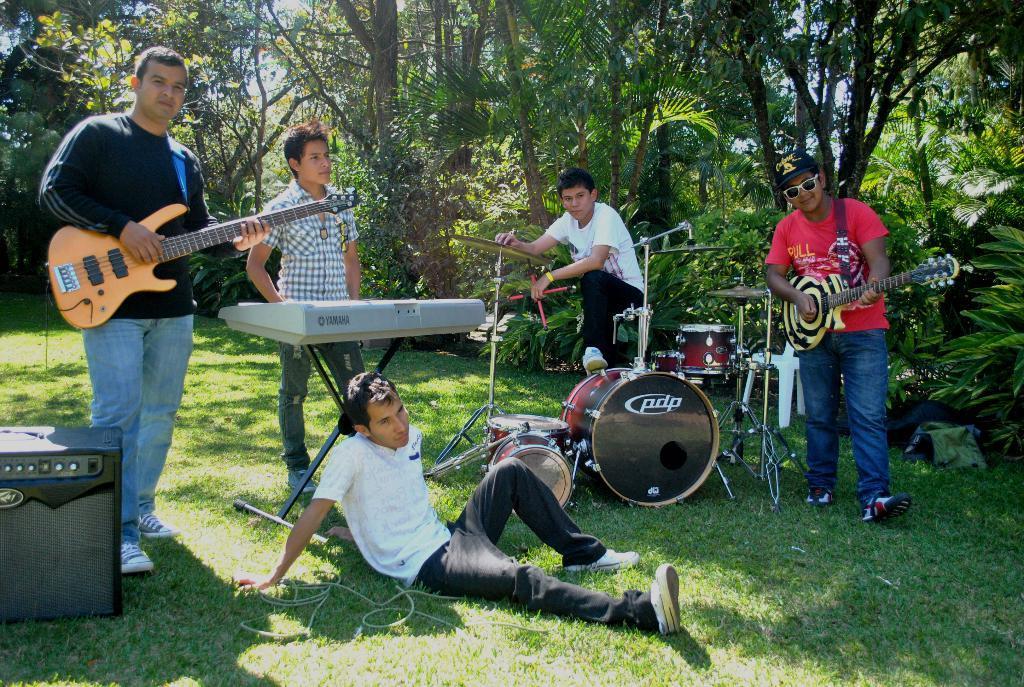Can you describe this image briefly? In this image i can see few people standing and a person sitting on the grass, 2 persons are holding guitar in their hands and i can see microphones and few musical instruments. In the background i can see trees and the sky. 